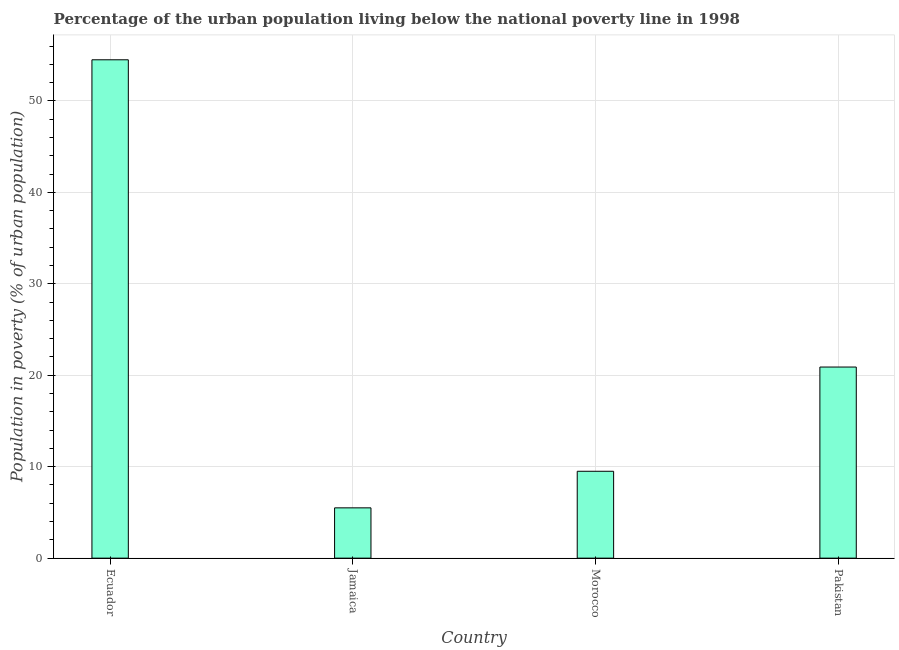Does the graph contain any zero values?
Ensure brevity in your answer.  No. What is the title of the graph?
Your answer should be compact. Percentage of the urban population living below the national poverty line in 1998. What is the label or title of the Y-axis?
Ensure brevity in your answer.  Population in poverty (% of urban population). What is the percentage of urban population living below poverty line in Ecuador?
Offer a terse response. 54.5. Across all countries, what is the maximum percentage of urban population living below poverty line?
Your response must be concise. 54.5. In which country was the percentage of urban population living below poverty line maximum?
Give a very brief answer. Ecuador. In which country was the percentage of urban population living below poverty line minimum?
Make the answer very short. Jamaica. What is the sum of the percentage of urban population living below poverty line?
Keep it short and to the point. 90.4. What is the difference between the percentage of urban population living below poverty line in Jamaica and Pakistan?
Your answer should be very brief. -15.4. What is the average percentage of urban population living below poverty line per country?
Ensure brevity in your answer.  22.6. What is the median percentage of urban population living below poverty line?
Your answer should be very brief. 15.2. What is the ratio of the percentage of urban population living below poverty line in Ecuador to that in Jamaica?
Provide a succinct answer. 9.91. Is the percentage of urban population living below poverty line in Ecuador less than that in Pakistan?
Offer a terse response. No. Is the difference between the percentage of urban population living below poverty line in Morocco and Pakistan greater than the difference between any two countries?
Provide a succinct answer. No. What is the difference between the highest and the second highest percentage of urban population living below poverty line?
Your answer should be very brief. 33.6. Is the sum of the percentage of urban population living below poverty line in Ecuador and Pakistan greater than the maximum percentage of urban population living below poverty line across all countries?
Ensure brevity in your answer.  Yes. What is the difference between the highest and the lowest percentage of urban population living below poverty line?
Make the answer very short. 49. In how many countries, is the percentage of urban population living below poverty line greater than the average percentage of urban population living below poverty line taken over all countries?
Provide a short and direct response. 1. What is the difference between two consecutive major ticks on the Y-axis?
Make the answer very short. 10. What is the Population in poverty (% of urban population) of Ecuador?
Provide a succinct answer. 54.5. What is the Population in poverty (% of urban population) in Pakistan?
Your answer should be very brief. 20.9. What is the difference between the Population in poverty (% of urban population) in Ecuador and Morocco?
Give a very brief answer. 45. What is the difference between the Population in poverty (% of urban population) in Ecuador and Pakistan?
Your answer should be very brief. 33.6. What is the difference between the Population in poverty (% of urban population) in Jamaica and Pakistan?
Offer a very short reply. -15.4. What is the difference between the Population in poverty (% of urban population) in Morocco and Pakistan?
Provide a short and direct response. -11.4. What is the ratio of the Population in poverty (% of urban population) in Ecuador to that in Jamaica?
Offer a very short reply. 9.91. What is the ratio of the Population in poverty (% of urban population) in Ecuador to that in Morocco?
Provide a short and direct response. 5.74. What is the ratio of the Population in poverty (% of urban population) in Ecuador to that in Pakistan?
Make the answer very short. 2.61. What is the ratio of the Population in poverty (% of urban population) in Jamaica to that in Morocco?
Provide a succinct answer. 0.58. What is the ratio of the Population in poverty (% of urban population) in Jamaica to that in Pakistan?
Make the answer very short. 0.26. What is the ratio of the Population in poverty (% of urban population) in Morocco to that in Pakistan?
Keep it short and to the point. 0.46. 